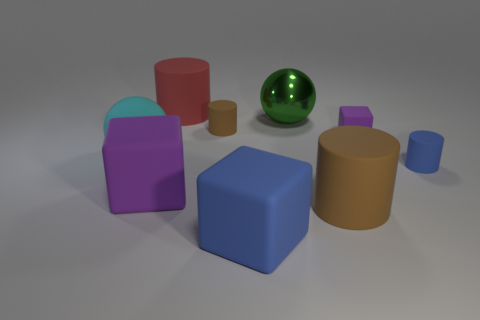Subtract all large blocks. How many blocks are left? 1 Add 1 brown matte things. How many objects exist? 10 Subtract all gray cylinders. How many purple blocks are left? 2 Subtract all brown cylinders. How many cylinders are left? 2 Subtract all cubes. How many objects are left? 6 Subtract 2 cylinders. How many cylinders are left? 2 Subtract all red blocks. Subtract all yellow spheres. How many blocks are left? 3 Add 5 small rubber blocks. How many small rubber blocks are left? 6 Add 6 green shiny things. How many green shiny things exist? 7 Subtract 1 blue cylinders. How many objects are left? 8 